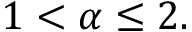<formula> <loc_0><loc_0><loc_500><loc_500>1 < \alpha \leq 2 .</formula> 